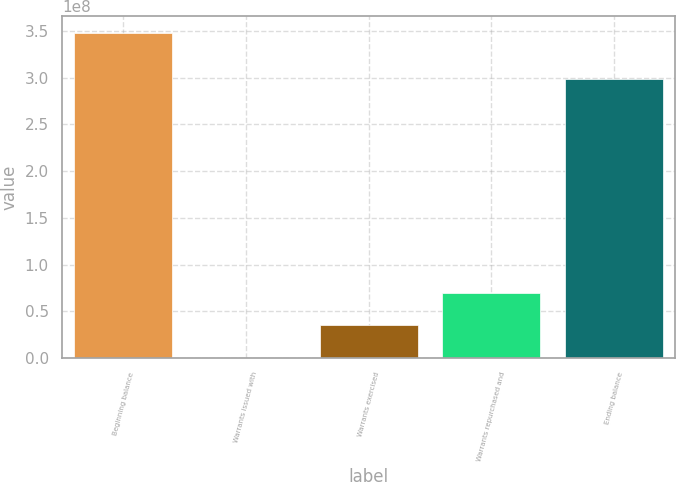Convert chart. <chart><loc_0><loc_0><loc_500><loc_500><bar_chart><fcel>Beginning balance<fcel>Warrants issued with<fcel>Warrants exercised<fcel>Warrants repurchased and<fcel>Ending balance<nl><fcel>3.47933e+08<fcel>4315<fcel>3.47972e+07<fcel>6.95901e+07<fcel>2.98136e+08<nl></chart> 